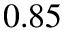Convert formula to latex. <formula><loc_0><loc_0><loc_500><loc_500>0 . 8 5</formula> 